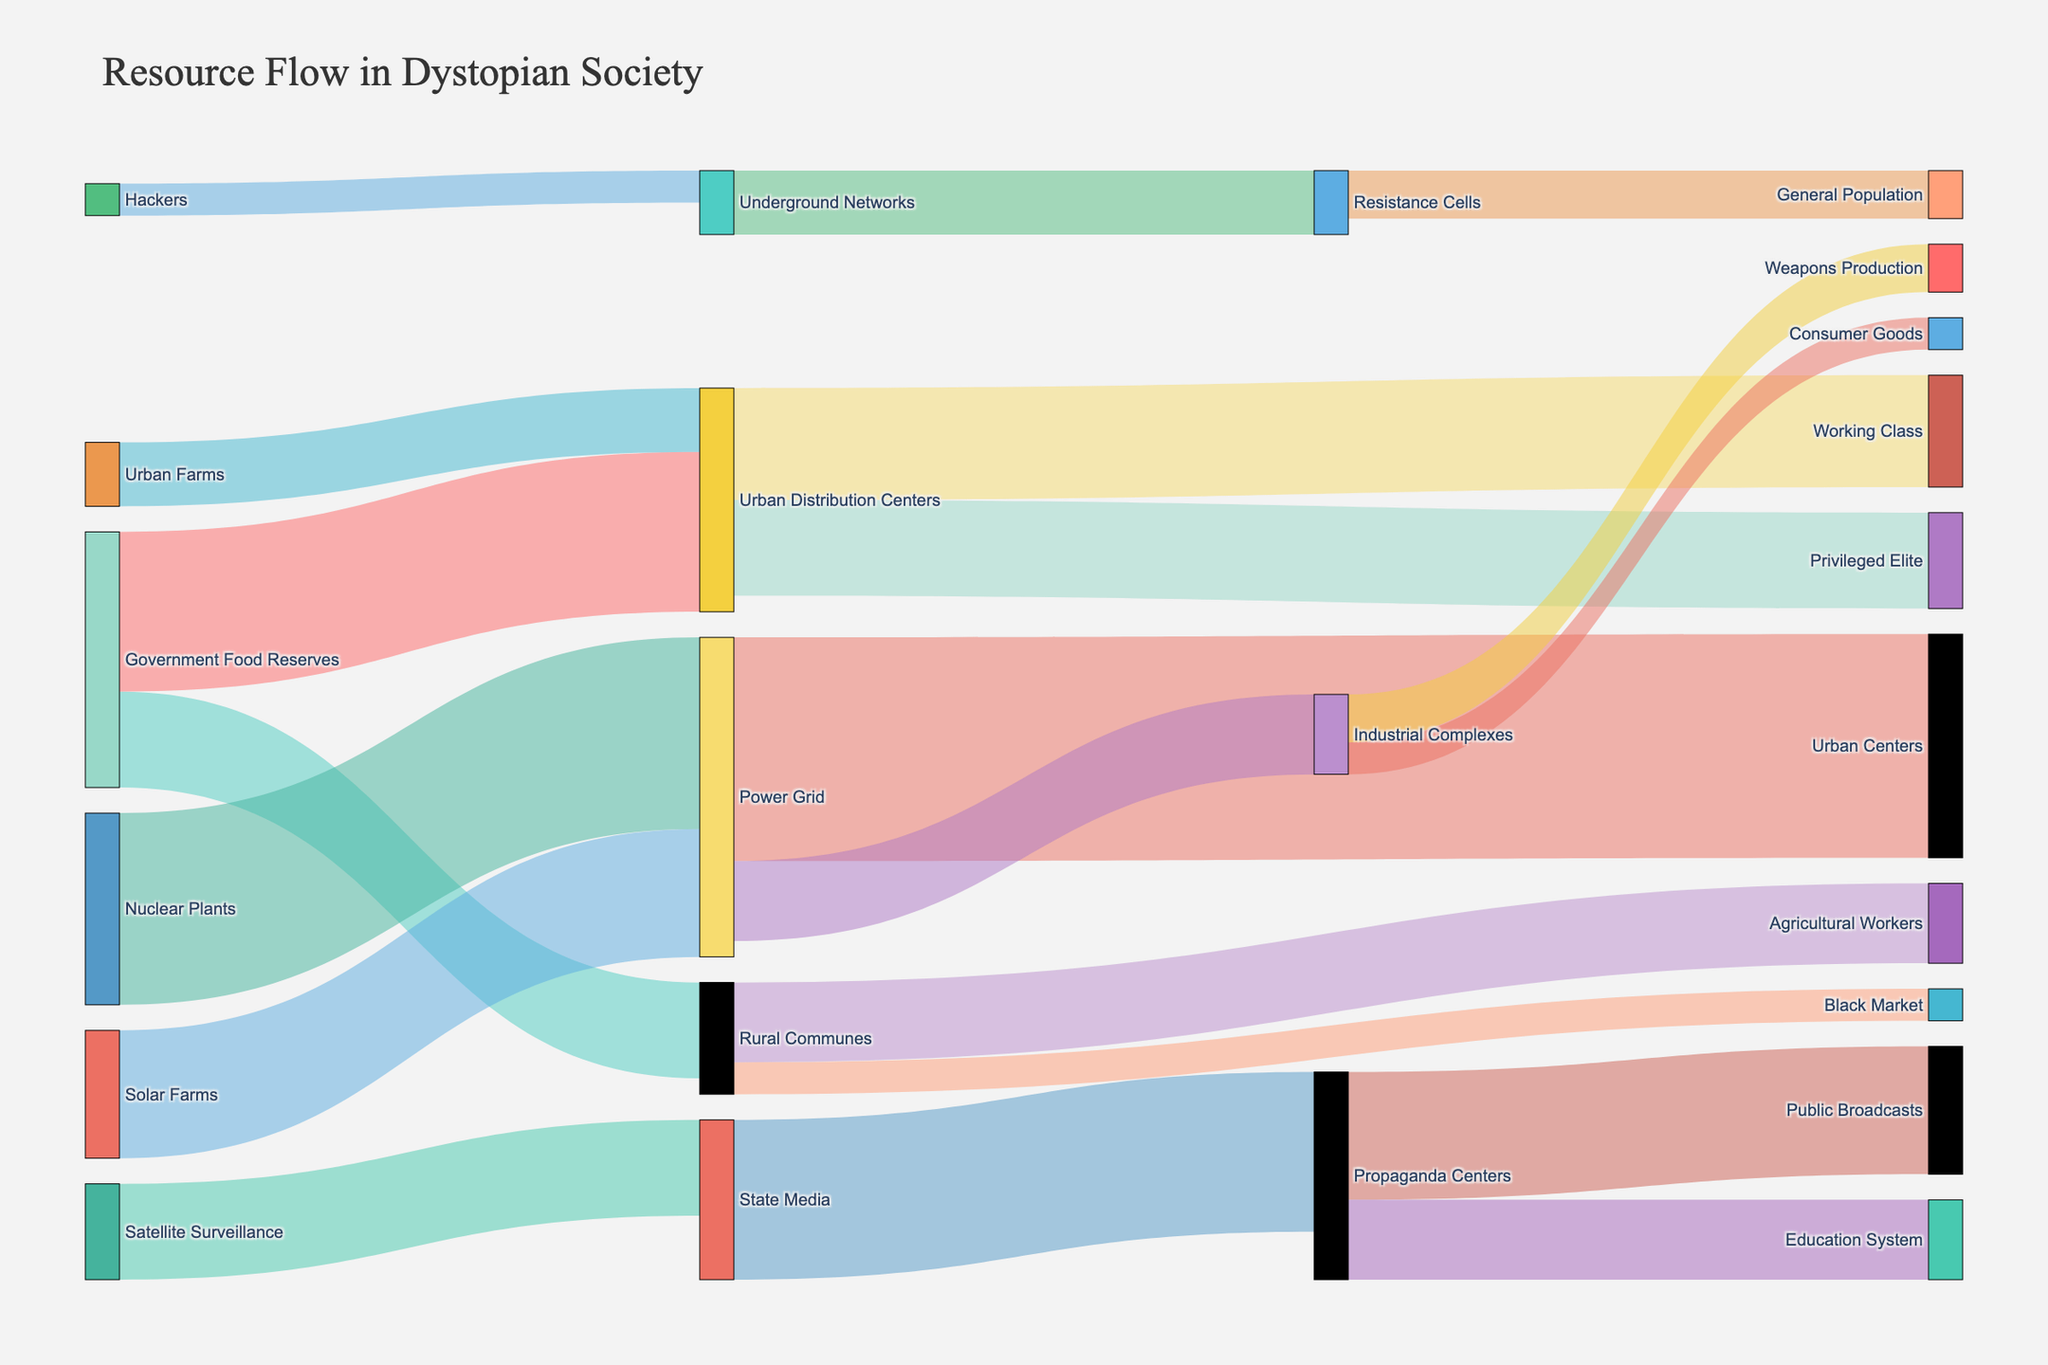Which entity receives the highest amount of food? To find out which entity receives the most food, we need to identify the target with the highest summed value in the food flow. Urban Distribution Centers receive 5000 from Government Food Reserves and 2000 from Urban Farms, totaling 7000. This is the highest amount.
Answer: Urban Distribution Centers How much total energy is generated by Solar Farms and Nuclear Plants? Add the values from Solar Farms and Nuclear Plants contributions to the Power Grid. Solar Farms contribute 4000 and Nuclear Plants contribute 6000, resulting in a total of 10000.
Answer: 10000 What is the next step after Propaganda Centers in the information flow? Look for the targets linked to Propaganda Centers. The next steps are Public Broadcasts and Education System.
Answer: Public Broadcasts and Education System Which target receives more from the Urban Distribution Centers, Privileged Elite or Working Class? Compare the flow values from Urban Distribution Centers to Privileged Elite (3000) and to Working Class (3500). Working Class receives more.
Answer: Working Class How does the flow of resources to the General Population occur? Trace the paths leading to General Population. Resources flow from Resistance Cells to General Population. Resistance Cells get their resources from Underground Networks.
Answer: Resistance Cells What is the total amount of resources that flow through the Power Grid? Calculate the sum of resources flowing out from the Power Grid. Urban Centers receive 7000 and Industrial Complexes receive 2500. The total is 9500.
Answer: 9500 Which entity contributes the highest amount of resources to Agricultural Workers? Identify the contribution from Rural Communes to Agricultural Workers, which is 2500. Rural Communes are the only contributor here.
Answer: Rural Communes How many resources are contributed to the Black Market? Only one contribution to the Black Market is shown, which comes from Rural Communes and amounts to 1000.
Answer: 1000 Which source contributes more resources to the Urban Distribution Centers, Government Food Reserves, or Urban Farms? Compare the contributions to Urban Distribution Centers. Government Food Reserves contribute 5000, while Urban Farms contribute 2000. Government Food Reserves contribute more.
Answer: Government Food Reserves What is the total amount of resources managed by Industrial Complexes? Add the values of resources flowing into Industrial Complexes. The Power Grid sends 2500 resources to Industrial Complexes.
Answer: 2500 